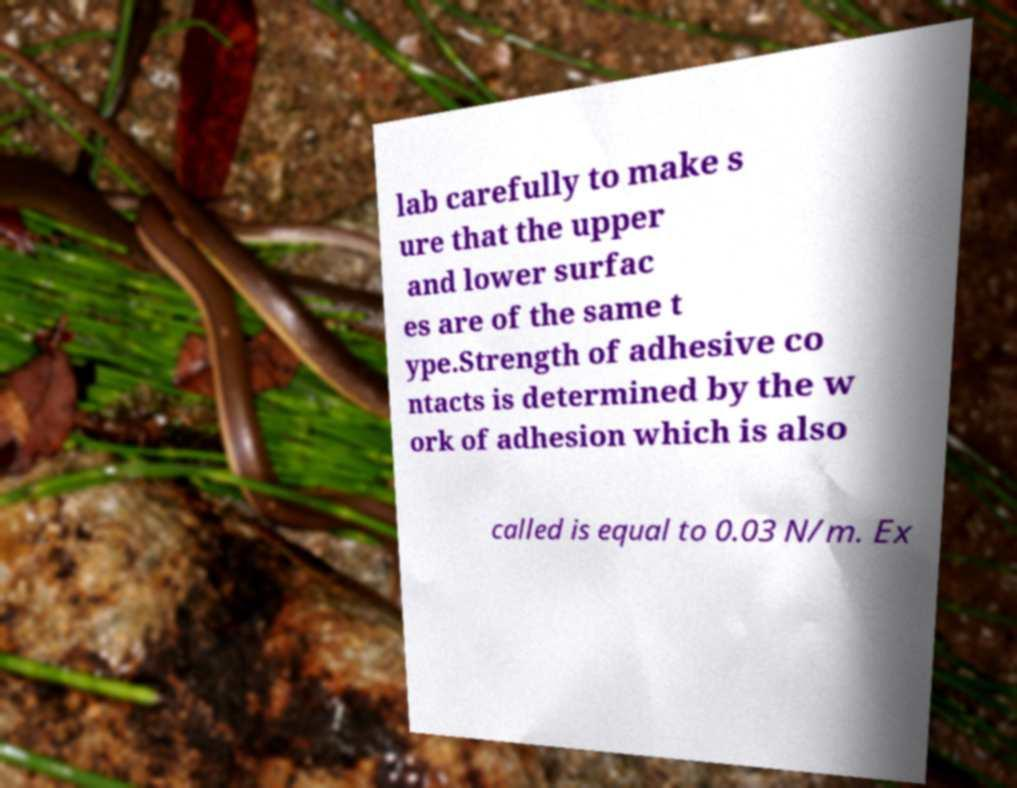Could you extract and type out the text from this image? lab carefully to make s ure that the upper and lower surfac es are of the same t ype.Strength of adhesive co ntacts is determined by the w ork of adhesion which is also called is equal to 0.03 N/m. Ex 